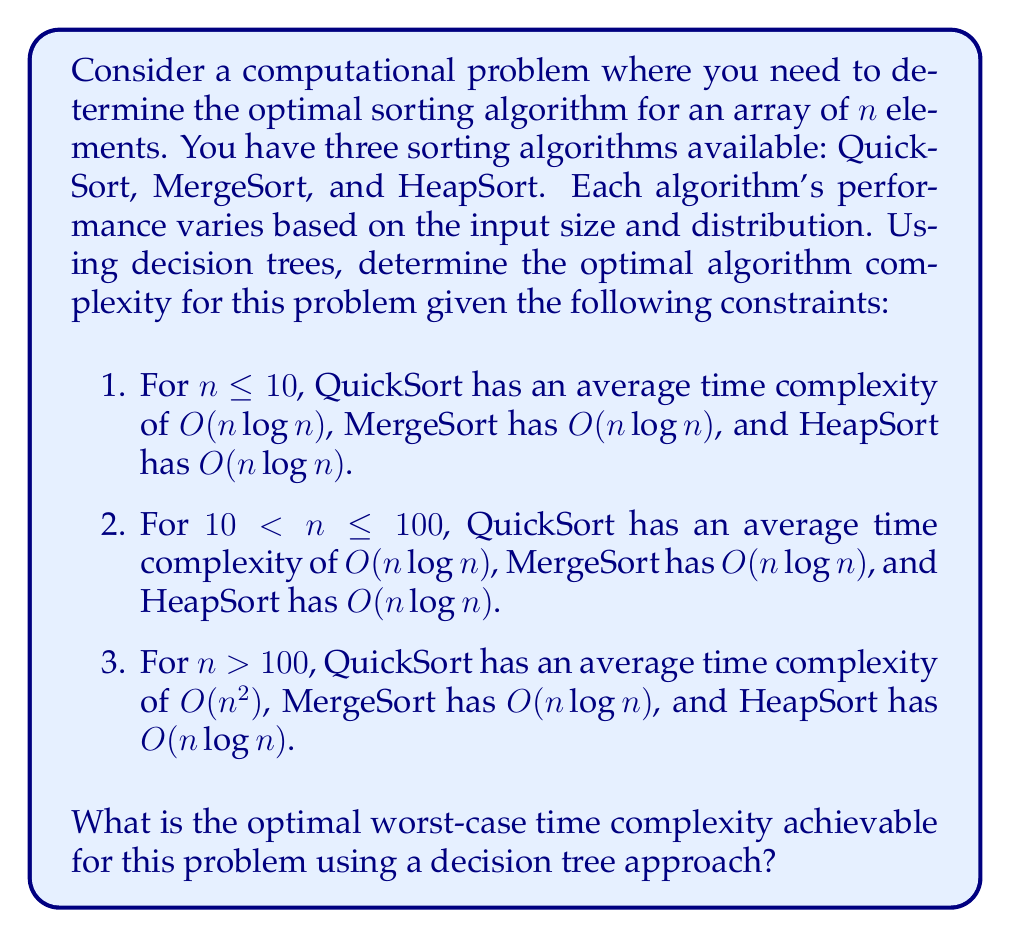What is the answer to this math problem? To solve this problem, we need to construct a decision tree based on the given constraints and determine the optimal algorithm for each case. Let's break it down step by step:

1. Construct the decision tree:

[asy]
import geometry;

pair A = (0,0);
pair B1 = (-3,-2);
pair B2 = (0,-2);
pair B3 = (3,-2);
pair C1 = (-4,-4);
pair C2 = (-2,-4);
pair C3 = (0,-4);
pair C4 = (2,-4);
pair C5 = (4,-4);

draw(A--B1--C1);
draw(A--B1--C2);
draw(A--B2--C3);
draw(A--B3--C4);
draw(A--B3--C5);

label("Root", A, N);
label("n ≤ 10", B1, W);
label("10 < n ≤ 100", B2, E);
label("n > 100", B3, E);
label("QuickSort", C1, S);
label("MergeSort", C2, S);
label("HeapSort", C3, S);
label("MergeSort", C4, S);
label("HeapSort", C5, S);
[/asy]

2. Analyze each case:

   a. For $n \leq 10$:
      All algorithms have $O(n \log n)$ complexity. We can choose any of them.

   b. For $10 < n \leq 100$:
      All algorithms have $O(n \log n)$ complexity. We can choose any of them.

   c. For $n > 100$:
      QuickSort has $O(n^2)$, while MergeSort and HeapSort have $O(n \log n)$.
      We should choose either MergeSort or HeapSort for this case.

3. Determine the optimal worst-case time complexity:
   The worst-case scenario occurs when $n > 100$, where we need to choose between MergeSort and HeapSort to avoid the $O(n^2)$ complexity of QuickSort.

4. Implement the decision tree in code:

```python
def optimal_sort(n, arr):
    if n <= 10:
        return quicksort(arr)  # or mergesort(arr) or heapsort(arr)
    elif n <= 100:
        return mergesort(arr)  # or quicksort(arr) or heapsort(arr)
    else:
        return heapsort(arr)  # or mergesort(arr)
```

5. Analyze the worst-case time complexity:
   In all cases, we can achieve a worst-case time complexity of $O(n \log n)$ by choosing the appropriate algorithm based on the input size.
Answer: The optimal worst-case time complexity achievable for this problem using a decision tree approach is $O(n \log n)$. 